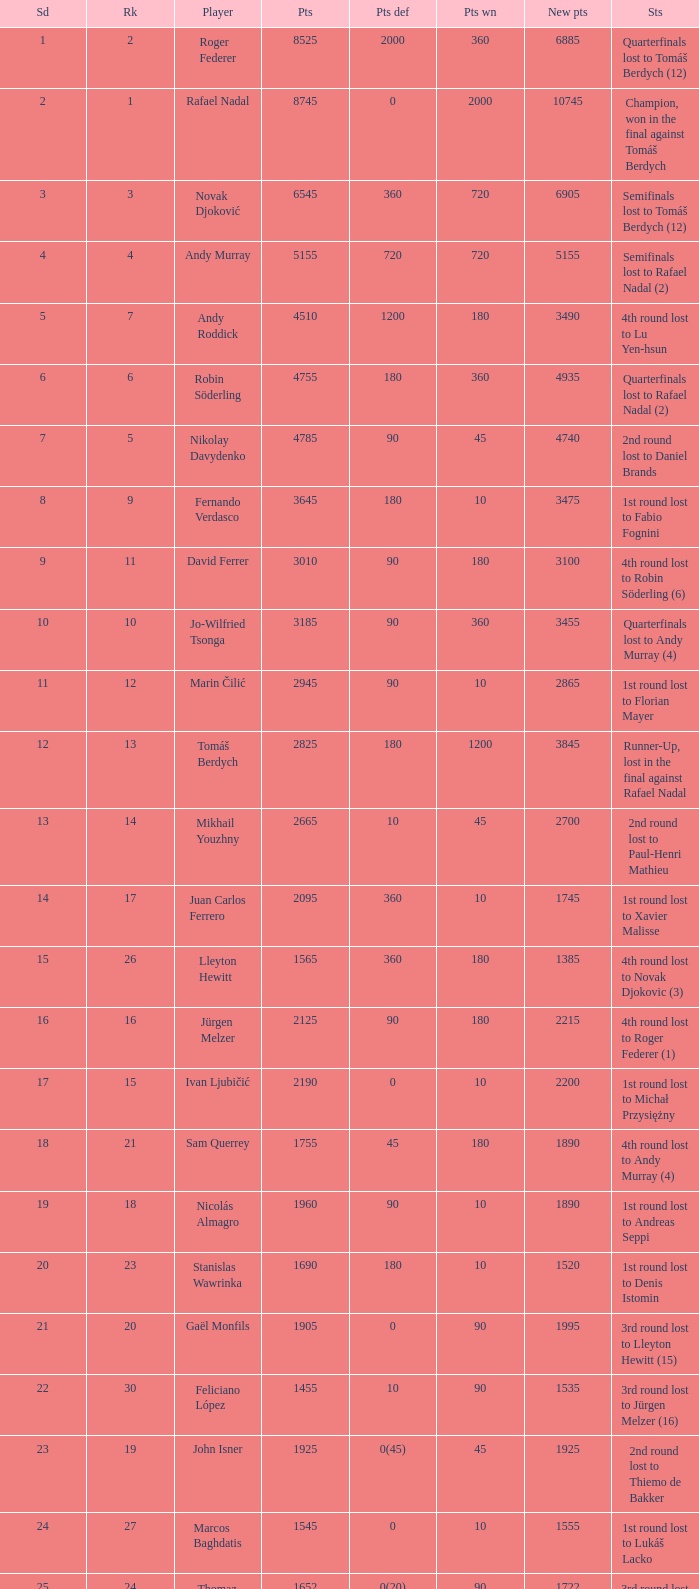Name the number of points defending for 1075 1.0. 